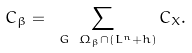<formula> <loc_0><loc_0><loc_500><loc_500>C _ { \beta } = \sum _ { \ G \ \Omega _ { \beta } \cap ( L ^ { n } + h ) } C _ { X } .</formula> 